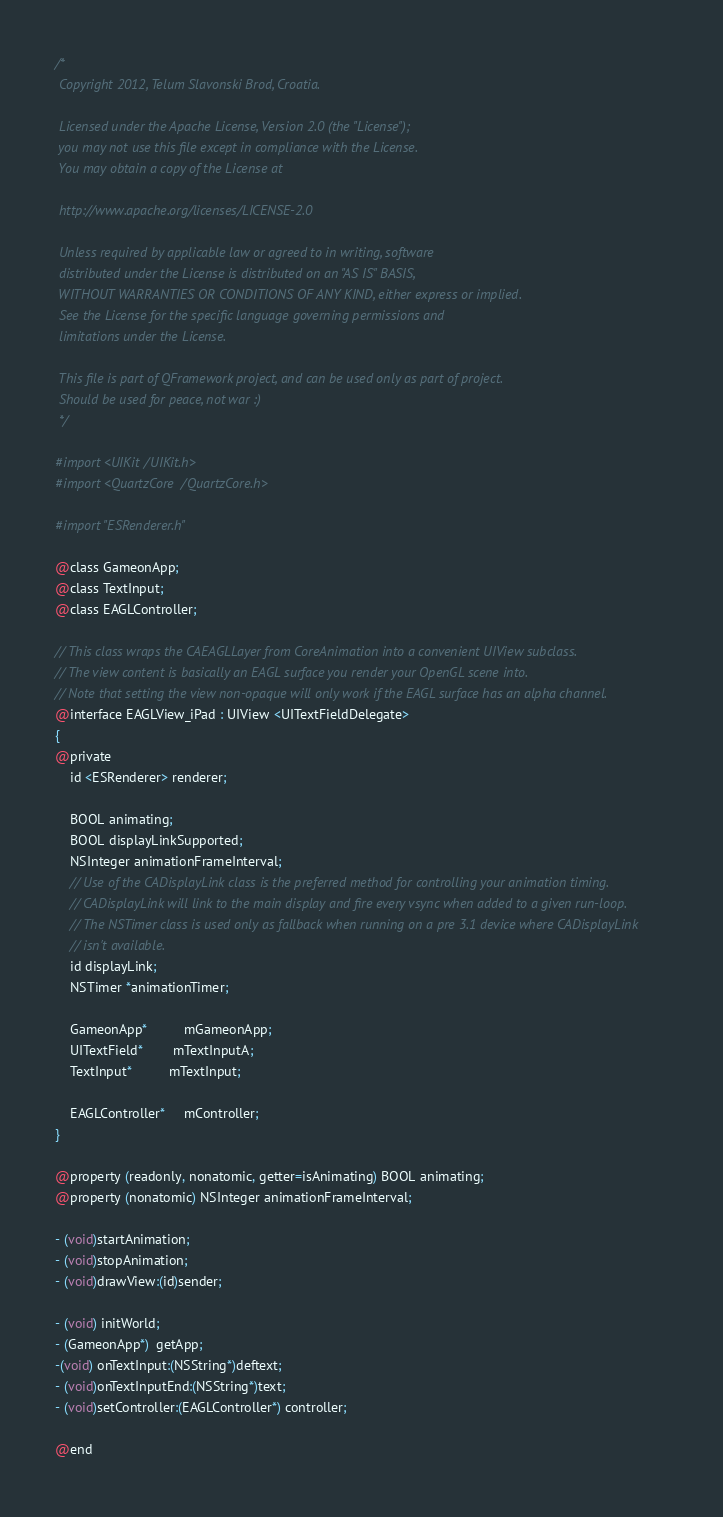<code> <loc_0><loc_0><loc_500><loc_500><_C_>/*
 Copyright 2012, Telum Slavonski Brod, Croatia.
 
 Licensed under the Apache License, Version 2.0 (the "License");
 you may not use this file except in compliance with the License.
 You may obtain a copy of the License at
 
 http://www.apache.org/licenses/LICENSE-2.0
 
 Unless required by applicable law or agreed to in writing, software
 distributed under the License is distributed on an "AS IS" BASIS,
 WITHOUT WARRANTIES OR CONDITIONS OF ANY KIND, either express or implied.
 See the License for the specific language governing permissions and
 limitations under the License.
 
 This file is part of QFramework project, and can be used only as part of project.
 Should be used for peace, not war :)   
 */

#import <UIKit/UIKit.h>
#import <QuartzCore/QuartzCore.h>

#import "ESRenderer.h"

@class GameonApp;
@class TextInput;
@class EAGLController;

// This class wraps the CAEAGLLayer from CoreAnimation into a convenient UIView subclass.
// The view content is basically an EAGL surface you render your OpenGL scene into.
// Note that setting the view non-opaque will only work if the EAGL surface has an alpha channel.
@interface EAGLView_iPad : UIView <UITextFieldDelegate>
{    
@private
    id <ESRenderer> renderer;

    BOOL animating;
    BOOL displayLinkSupported;
    NSInteger animationFrameInterval;
    // Use of the CADisplayLink class is the preferred method for controlling your animation timing.
    // CADisplayLink will link to the main display and fire every vsync when added to a given run-loop.
    // The NSTimer class is used only as fallback when running on a pre 3.1 device where CADisplayLink
    // isn't available.
    id displayLink;
    NSTimer *animationTimer;
    
    GameonApp*          mGameonApp;
    UITextField*        mTextInputA;    
    TextInput*          mTextInput;    
    
    EAGLController*     mController;
}

@property (readonly, nonatomic, getter=isAnimating) BOOL animating;
@property (nonatomic) NSInteger animationFrameInterval;

- (void)startAnimation;
- (void)stopAnimation;
- (void)drawView:(id)sender;

- (void) initWorld;
- (GameonApp*)  getApp;
-(void) onTextInput:(NSString*)deftext;
- (void)onTextInputEnd:(NSString*)text;
- (void)setController:(EAGLController*) controller;

@end
</code> 